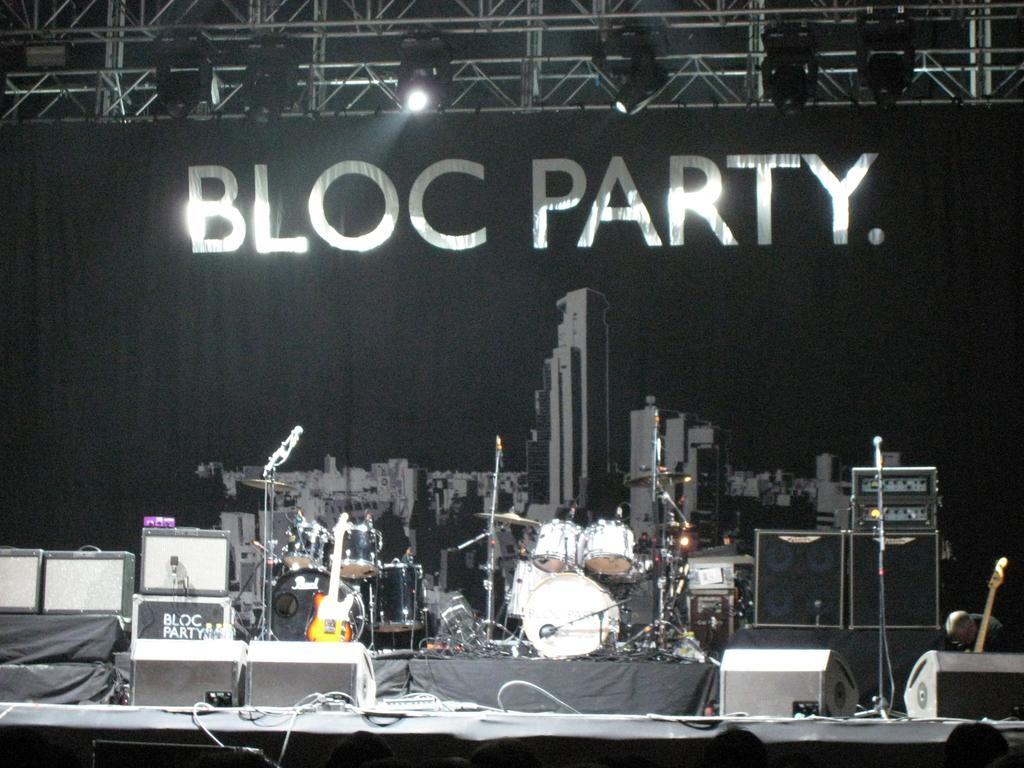What objects can be seen in the image related to music? There are musical instruments in the image. What can be seen at the top of the image? There are lights at the top of the image. What additional element is present in the image? There is a banner in the image. How many pots are visible in the image? There are no pots present in the image. What type of scene is depicted in the image? The image does not depict a scene; it contains musical instruments, lights, and a banner. 